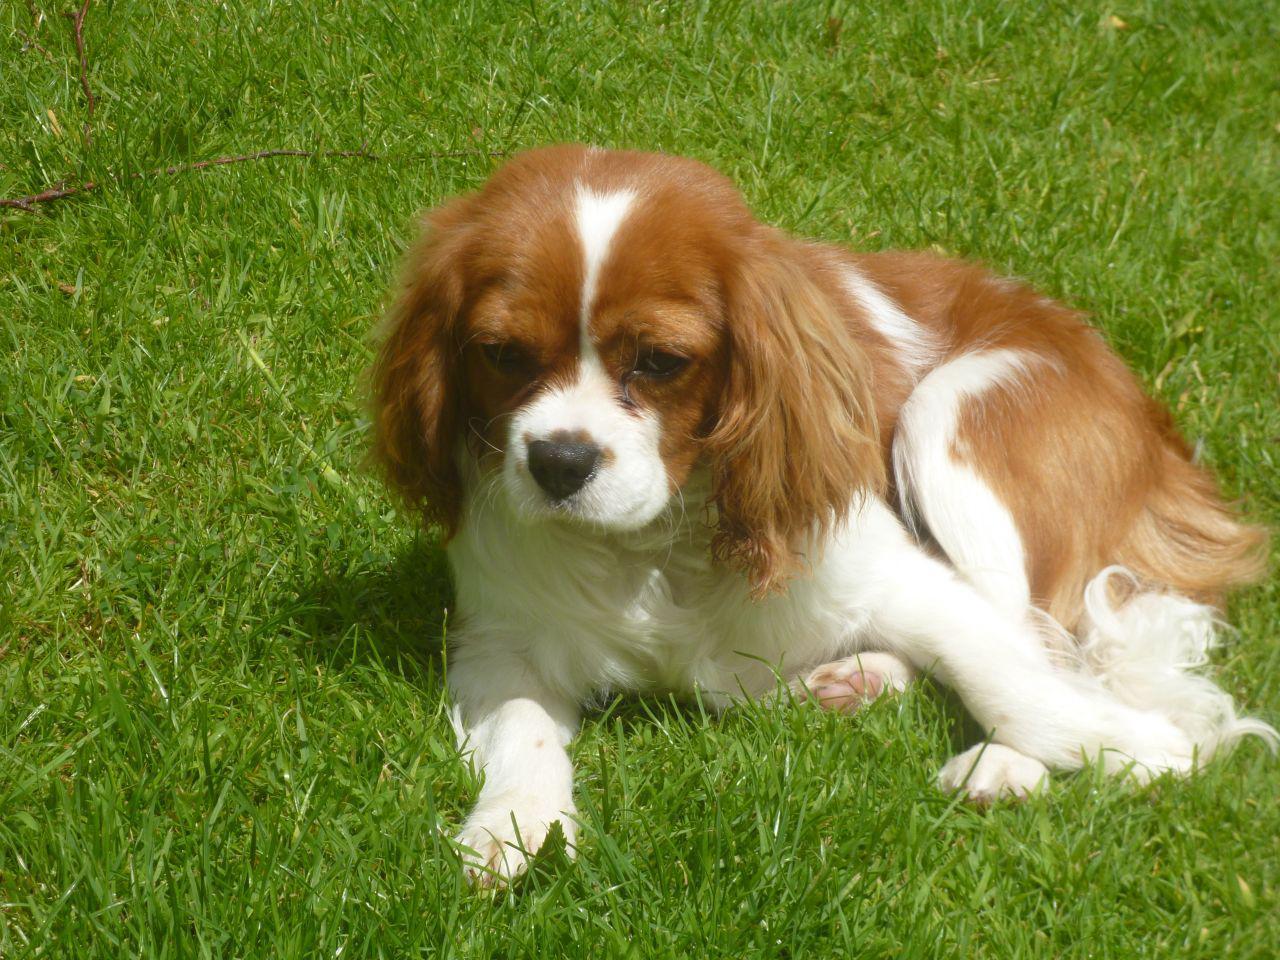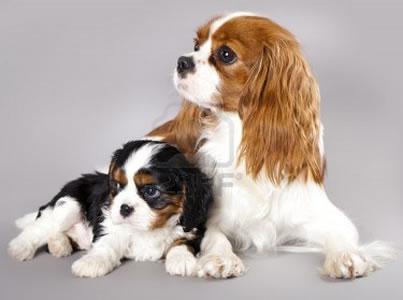The first image is the image on the left, the second image is the image on the right. Given the left and right images, does the statement "the right image has a dog on a brwon floor with a tan pillar behind them" hold true? Answer yes or no. No. The first image is the image on the left, the second image is the image on the right. For the images displayed, is the sentence "In one image there is a lone Cavalier King Charles Spaniel laying down looking at the camera in the center of the image." factually correct? Answer yes or no. No. 